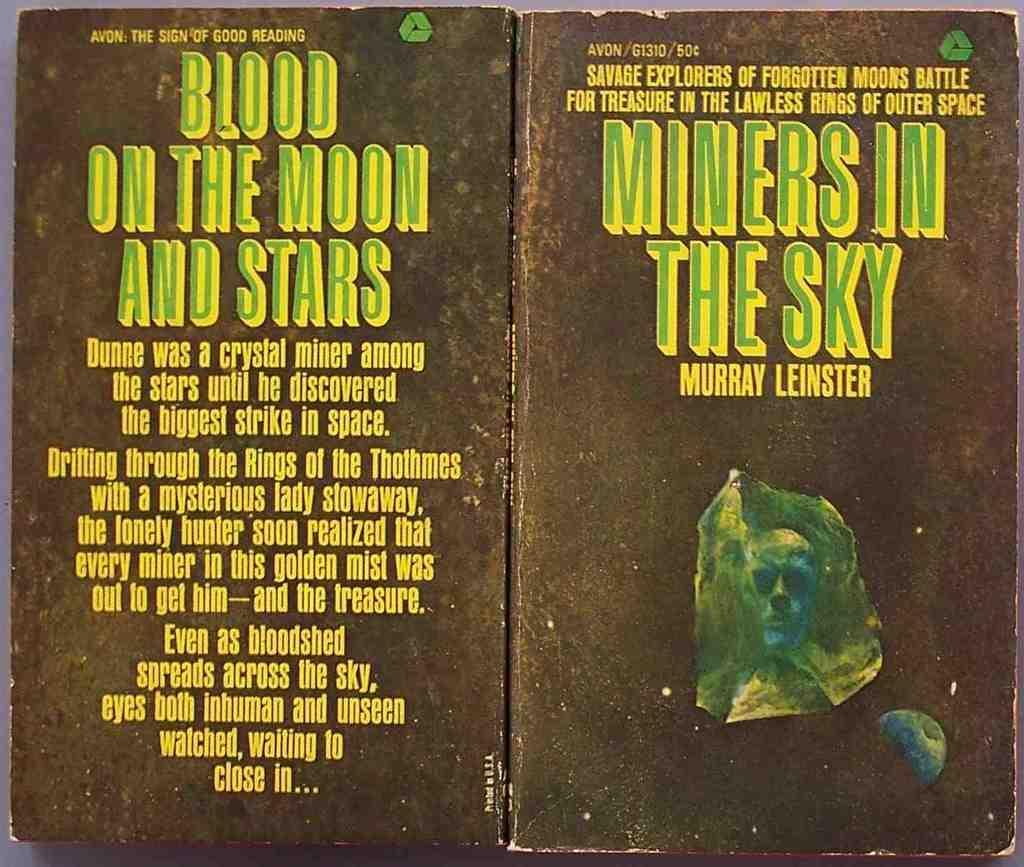<image>
Relay a brief, clear account of the picture shown. The front and back of the book Miners in the Sky by Murray Leinster is shown. 